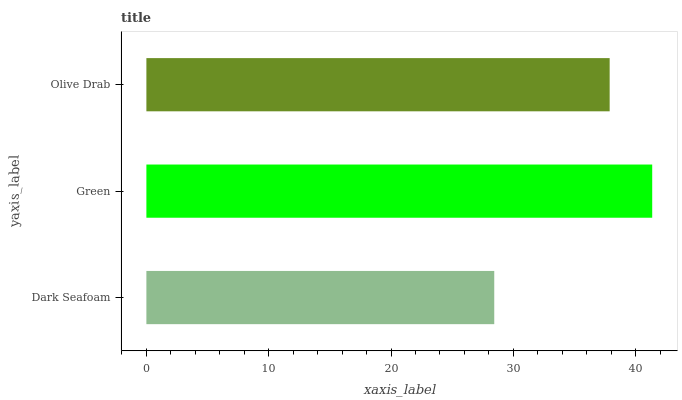Is Dark Seafoam the minimum?
Answer yes or no. Yes. Is Green the maximum?
Answer yes or no. Yes. Is Olive Drab the minimum?
Answer yes or no. No. Is Olive Drab the maximum?
Answer yes or no. No. Is Green greater than Olive Drab?
Answer yes or no. Yes. Is Olive Drab less than Green?
Answer yes or no. Yes. Is Olive Drab greater than Green?
Answer yes or no. No. Is Green less than Olive Drab?
Answer yes or no. No. Is Olive Drab the high median?
Answer yes or no. Yes. Is Olive Drab the low median?
Answer yes or no. Yes. Is Green the high median?
Answer yes or no. No. Is Green the low median?
Answer yes or no. No. 